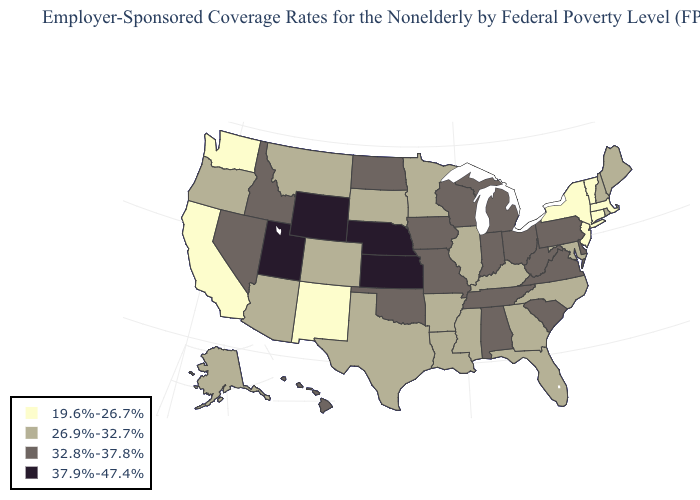What is the highest value in states that border West Virginia?
Be succinct. 32.8%-37.8%. Name the states that have a value in the range 32.8%-37.8%?
Answer briefly. Alabama, Delaware, Hawaii, Idaho, Indiana, Iowa, Michigan, Missouri, Nevada, North Dakota, Ohio, Oklahoma, Pennsylvania, South Carolina, Tennessee, Virginia, West Virginia, Wisconsin. What is the value of California?
Short answer required. 19.6%-26.7%. What is the value of Utah?
Concise answer only. 37.9%-47.4%. Does Florida have the lowest value in the South?
Concise answer only. Yes. Name the states that have a value in the range 19.6%-26.7%?
Give a very brief answer. California, Connecticut, Massachusetts, New Jersey, New Mexico, New York, Vermont, Washington. What is the value of North Dakota?
Quick response, please. 32.8%-37.8%. What is the value of Texas?
Be succinct. 26.9%-32.7%. How many symbols are there in the legend?
Answer briefly. 4. Does Iowa have the lowest value in the MidWest?
Short answer required. No. Name the states that have a value in the range 37.9%-47.4%?
Give a very brief answer. Kansas, Nebraska, Utah, Wyoming. What is the lowest value in the USA?
Keep it brief. 19.6%-26.7%. Name the states that have a value in the range 19.6%-26.7%?
Be succinct. California, Connecticut, Massachusetts, New Jersey, New Mexico, New York, Vermont, Washington. Does Minnesota have the highest value in the MidWest?
Short answer required. No. Does Kentucky have the highest value in the South?
Give a very brief answer. No. 